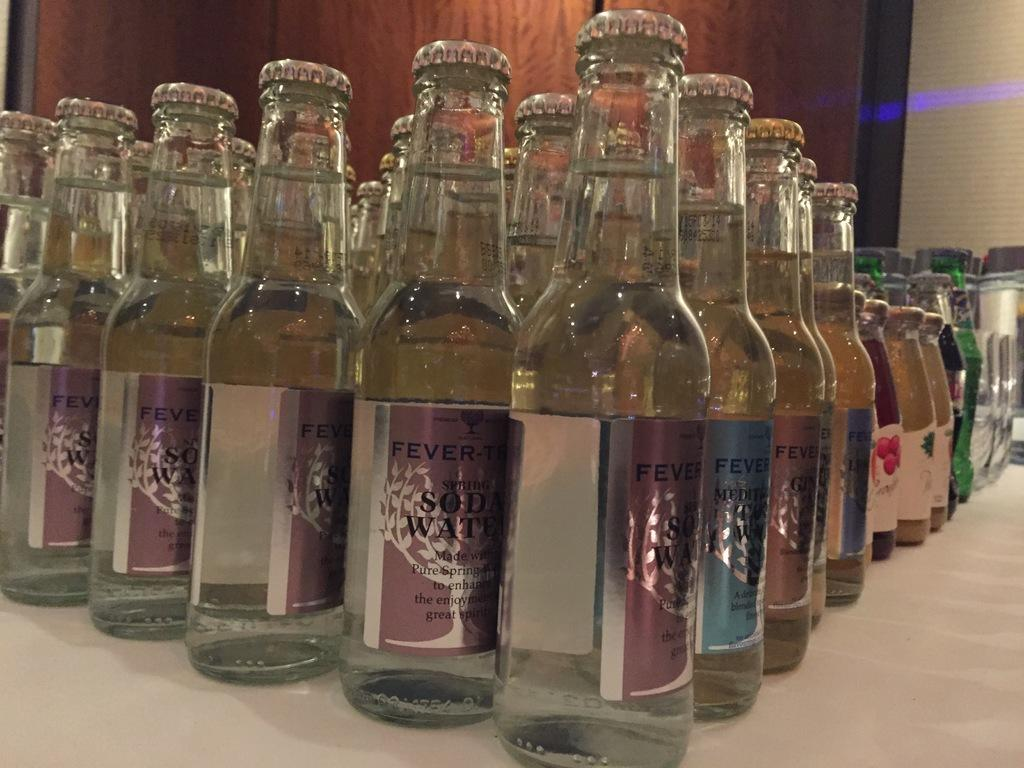Provide a one-sentence caption for the provided image. Several bottles of soda water sit on a table. 